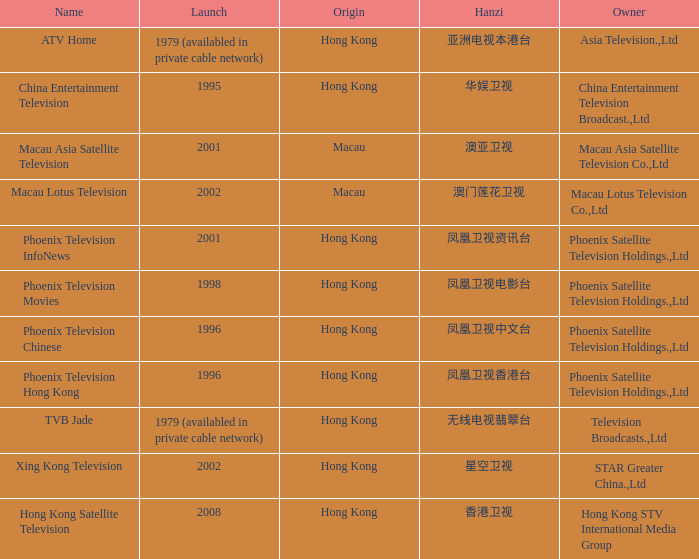Where did the Hanzi of 凤凰卫视电影台 originate? Hong Kong. 